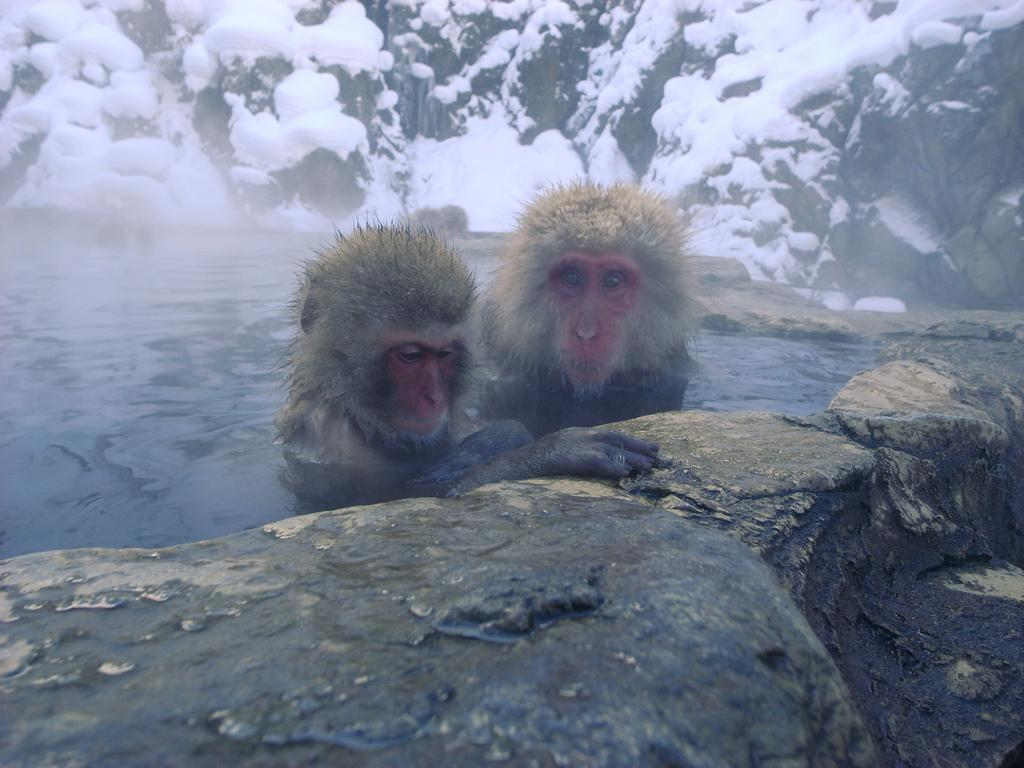What animals are in the water in the image? There are two monkeys in the water in the image. What can be seen in the background of the image? The background of the image includes snow. What language do the monkeys speak in the image? Monkeys do not speak a language, so this cannot be determined from the image. 